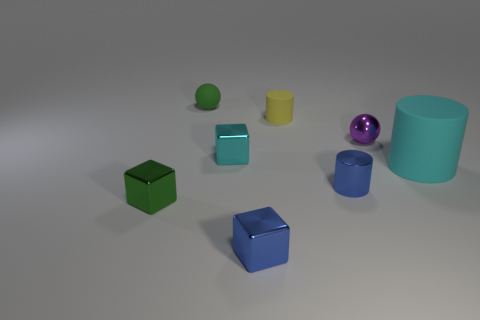There is a matte object that is to the right of the green rubber thing and to the left of the blue metal cylinder; what color is it?
Provide a succinct answer. Yellow. Is there another shiny object of the same color as the big object?
Offer a very short reply. Yes. Do the cyan object that is to the left of the yellow rubber cylinder and the small green sphere to the right of the small green metallic block have the same material?
Keep it short and to the point. No. How big is the rubber cylinder right of the metal cylinder?
Your answer should be compact. Large. How big is the cyan cylinder?
Make the answer very short. Large. There is a blue thing right of the cylinder that is behind the sphere to the right of the green matte ball; how big is it?
Give a very brief answer. Small. Is there a thing made of the same material as the small yellow cylinder?
Your response must be concise. Yes. What shape is the big thing?
Keep it short and to the point. Cylinder. There is another big thing that is made of the same material as the yellow thing; what color is it?
Offer a very short reply. Cyan. What number of brown objects are either large things or big matte blocks?
Your response must be concise. 0. 